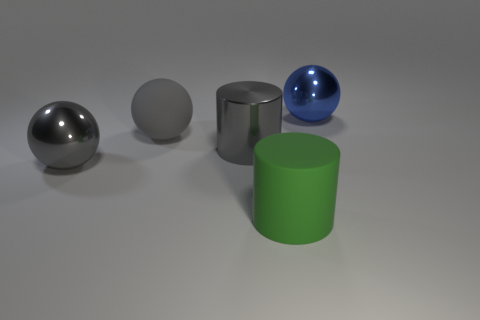Does the thing right of the rubber cylinder have the same material as the gray cylinder that is behind the green matte object?
Provide a succinct answer. Yes. Is there anything else that is the same shape as the big blue object?
Your answer should be compact. Yes. Do the large blue ball and the gray thing to the left of the matte sphere have the same material?
Offer a very short reply. Yes. What color is the cylinder left of the rubber object that is in front of the big gray ball that is left of the big matte sphere?
Give a very brief answer. Gray. What is the shape of the blue metal object that is the same size as the gray shiny sphere?
Give a very brief answer. Sphere. Is there any other thing that is the same size as the blue metallic sphere?
Provide a succinct answer. Yes. Does the rubber object on the left side of the green cylinder have the same size as the shiny sphere left of the blue ball?
Offer a very short reply. Yes. There is a object that is left of the rubber sphere; what size is it?
Provide a succinct answer. Large. There is a cylinder that is the same color as the rubber sphere; what is it made of?
Your answer should be very brief. Metal. The matte sphere that is the same size as the green cylinder is what color?
Your answer should be very brief. Gray. 